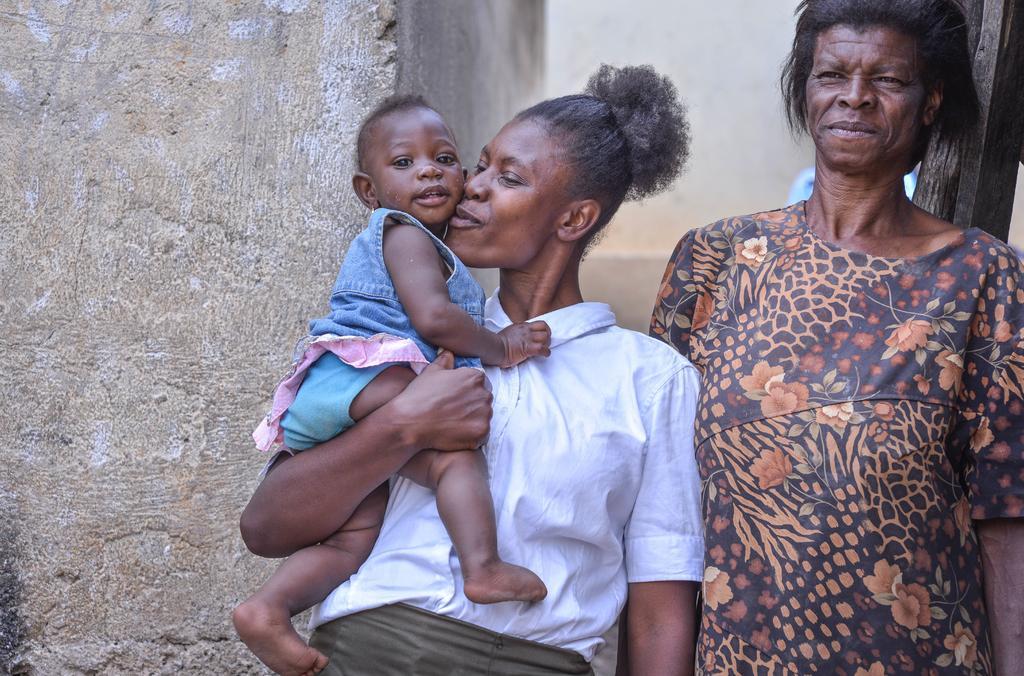Could you give a brief overview of what you see in this image? In the center of the image we can see two persons are standing and they are in different costumes. And the left side person is holding a kid and she is smiling. In the background there is a wall and a few other objects. 